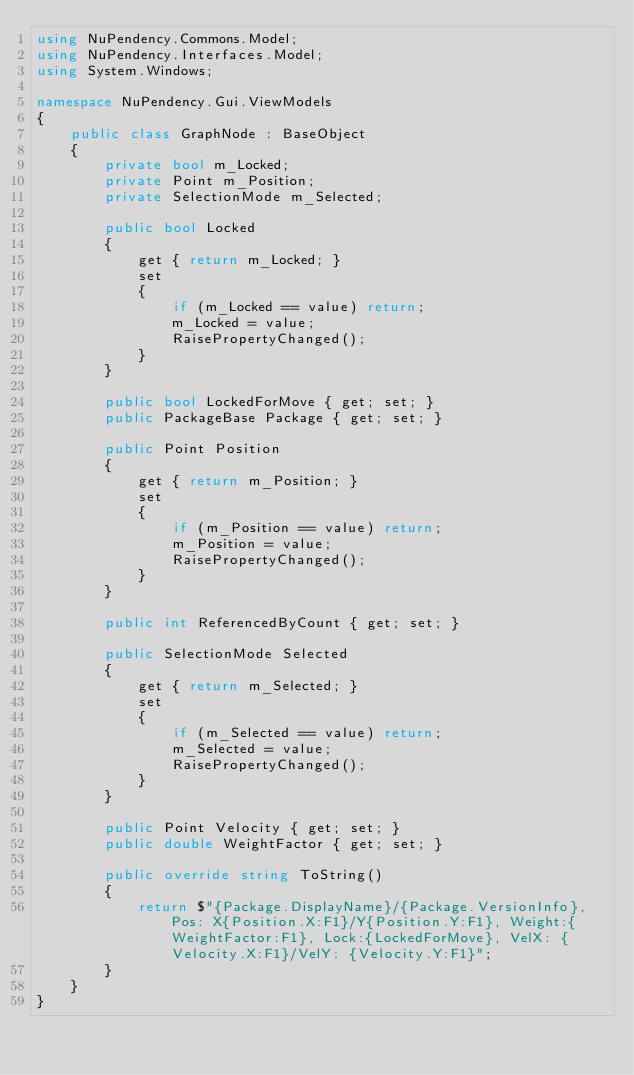Convert code to text. <code><loc_0><loc_0><loc_500><loc_500><_C#_>using NuPendency.Commons.Model;
using NuPendency.Interfaces.Model;
using System.Windows;

namespace NuPendency.Gui.ViewModels
{
    public class GraphNode : BaseObject
    {
        private bool m_Locked;
        private Point m_Position;
        private SelectionMode m_Selected;

        public bool Locked
        {
            get { return m_Locked; }
            set
            {
                if (m_Locked == value) return;
                m_Locked = value;
                RaisePropertyChanged();
            }
        }

        public bool LockedForMove { get; set; }
        public PackageBase Package { get; set; }

        public Point Position
        {
            get { return m_Position; }
            set
            {
                if (m_Position == value) return;
                m_Position = value;
                RaisePropertyChanged();
            }
        }

        public int ReferencedByCount { get; set; }

        public SelectionMode Selected
        {
            get { return m_Selected; }
            set
            {
                if (m_Selected == value) return;
                m_Selected = value;
                RaisePropertyChanged();
            }
        }

        public Point Velocity { get; set; }
        public double WeightFactor { get; set; }

        public override string ToString()
        {
            return $"{Package.DisplayName}/{Package.VersionInfo}, Pos: X{Position.X:F1}/Y{Position.Y:F1}, Weight:{WeightFactor:F1}, Lock:{LockedForMove}, VelX: {Velocity.X:F1}/VelY: {Velocity.Y:F1}";
        }
    }
}</code> 